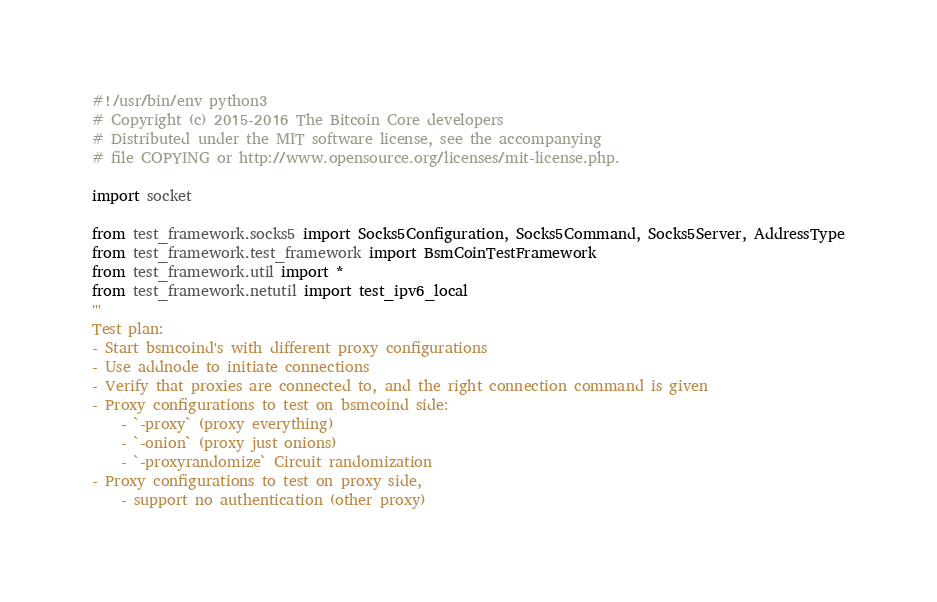Convert code to text. <code><loc_0><loc_0><loc_500><loc_500><_Python_>#!/usr/bin/env python3
# Copyright (c) 2015-2016 The Bitcoin Core developers
# Distributed under the MIT software license, see the accompanying
# file COPYING or http://www.opensource.org/licenses/mit-license.php.

import socket

from test_framework.socks5 import Socks5Configuration, Socks5Command, Socks5Server, AddressType
from test_framework.test_framework import BsmCoinTestFramework
from test_framework.util import *
from test_framework.netutil import test_ipv6_local
'''
Test plan:
- Start bsmcoind's with different proxy configurations
- Use addnode to initiate connections
- Verify that proxies are connected to, and the right connection command is given
- Proxy configurations to test on bsmcoind side:
    - `-proxy` (proxy everything)
    - `-onion` (proxy just onions)
    - `-proxyrandomize` Circuit randomization
- Proxy configurations to test on proxy side,
    - support no authentication (other proxy)</code> 